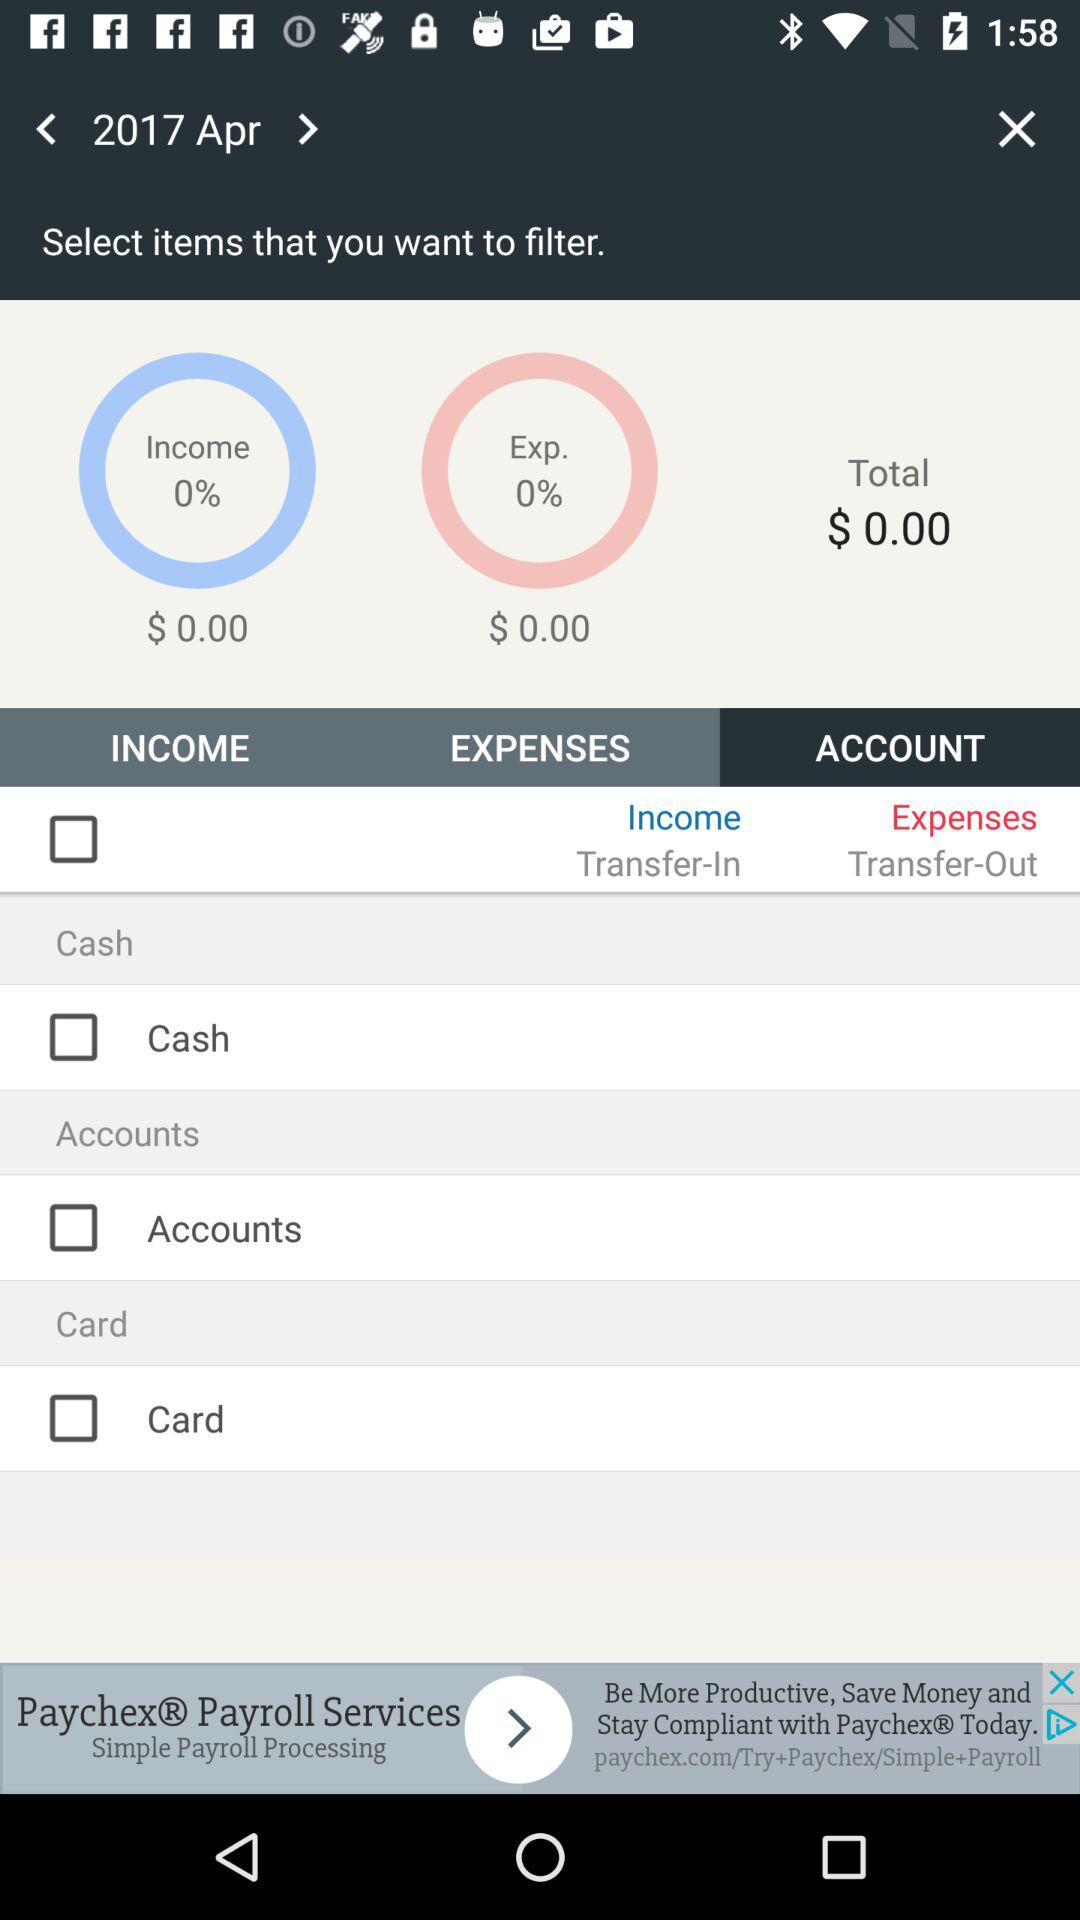What is the total balance? The total balance is $0.00. 